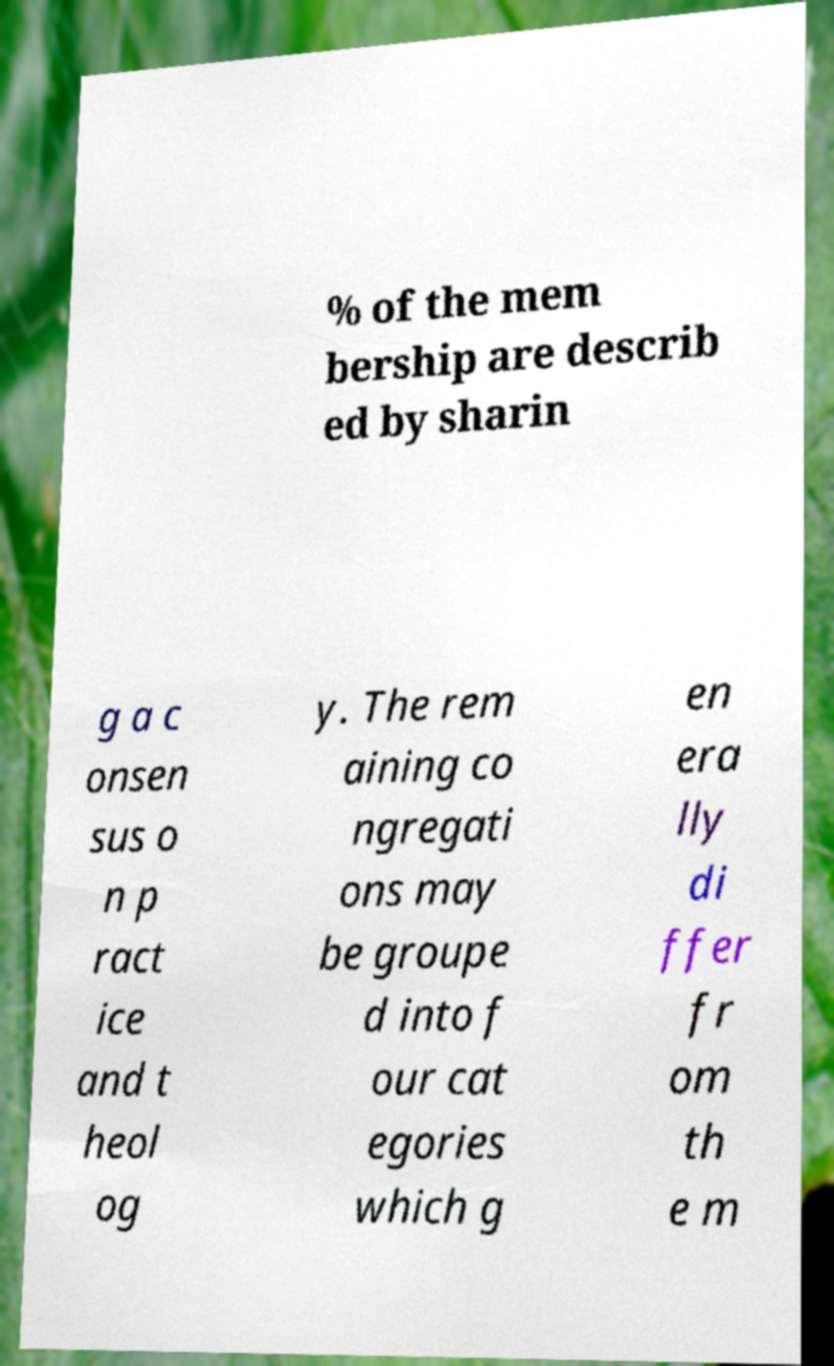Can you read and provide the text displayed in the image?This photo seems to have some interesting text. Can you extract and type it out for me? % of the mem bership are describ ed by sharin g a c onsen sus o n p ract ice and t heol og y. The rem aining co ngregati ons may be groupe d into f our cat egories which g en era lly di ffer fr om th e m 